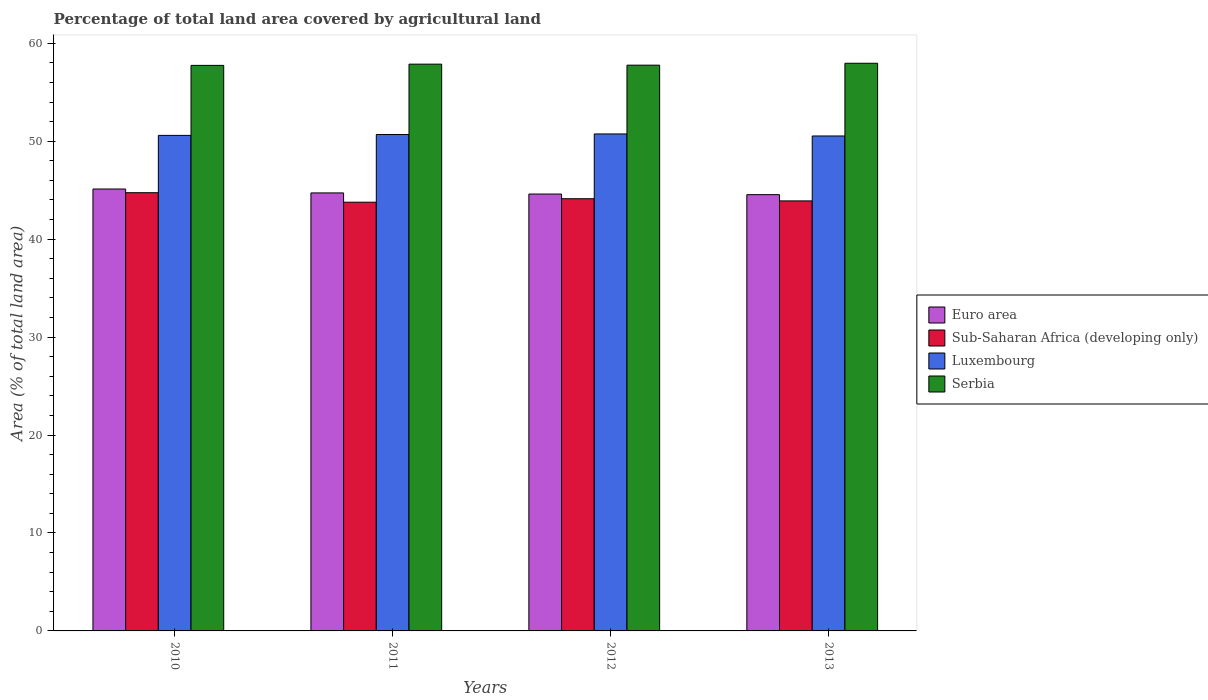Are the number of bars per tick equal to the number of legend labels?
Your answer should be compact. Yes. How many bars are there on the 2nd tick from the left?
Offer a terse response. 4. What is the label of the 4th group of bars from the left?
Keep it short and to the point. 2013. What is the percentage of agricultural land in Sub-Saharan Africa (developing only) in 2011?
Ensure brevity in your answer.  43.77. Across all years, what is the maximum percentage of agricultural land in Euro area?
Your answer should be compact. 45.12. Across all years, what is the minimum percentage of agricultural land in Serbia?
Make the answer very short. 57.74. In which year was the percentage of agricultural land in Serbia maximum?
Your answer should be very brief. 2013. In which year was the percentage of agricultural land in Serbia minimum?
Your response must be concise. 2010. What is the total percentage of agricultural land in Luxembourg in the graph?
Offer a very short reply. 202.55. What is the difference between the percentage of agricultural land in Serbia in 2010 and that in 2013?
Give a very brief answer. -0.22. What is the difference between the percentage of agricultural land in Serbia in 2011 and the percentage of agricultural land in Luxembourg in 2013?
Your answer should be very brief. 7.33. What is the average percentage of agricultural land in Serbia per year?
Your response must be concise. 57.83. In the year 2011, what is the difference between the percentage of agricultural land in Euro area and percentage of agricultural land in Sub-Saharan Africa (developing only)?
Offer a very short reply. 0.95. What is the ratio of the percentage of agricultural land in Sub-Saharan Africa (developing only) in 2011 to that in 2013?
Provide a succinct answer. 1. Is the difference between the percentage of agricultural land in Euro area in 2011 and 2013 greater than the difference between the percentage of agricultural land in Sub-Saharan Africa (developing only) in 2011 and 2013?
Ensure brevity in your answer.  Yes. What is the difference between the highest and the second highest percentage of agricultural land in Sub-Saharan Africa (developing only)?
Provide a short and direct response. 0.62. What is the difference between the highest and the lowest percentage of agricultural land in Serbia?
Keep it short and to the point. 0.22. What does the 4th bar from the left in 2012 represents?
Your response must be concise. Serbia. What does the 1st bar from the right in 2013 represents?
Ensure brevity in your answer.  Serbia. Is it the case that in every year, the sum of the percentage of agricultural land in Serbia and percentage of agricultural land in Luxembourg is greater than the percentage of agricultural land in Euro area?
Make the answer very short. Yes. How many bars are there?
Your response must be concise. 16. Are all the bars in the graph horizontal?
Ensure brevity in your answer.  No. What is the difference between two consecutive major ticks on the Y-axis?
Offer a very short reply. 10. Are the values on the major ticks of Y-axis written in scientific E-notation?
Ensure brevity in your answer.  No. Where does the legend appear in the graph?
Give a very brief answer. Center right. What is the title of the graph?
Make the answer very short. Percentage of total land area covered by agricultural land. Does "Albania" appear as one of the legend labels in the graph?
Offer a terse response. No. What is the label or title of the X-axis?
Ensure brevity in your answer.  Years. What is the label or title of the Y-axis?
Offer a very short reply. Area (% of total land area). What is the Area (% of total land area) in Euro area in 2010?
Your answer should be very brief. 45.12. What is the Area (% of total land area) of Sub-Saharan Africa (developing only) in 2010?
Offer a terse response. 44.74. What is the Area (% of total land area) in Luxembourg in 2010?
Make the answer very short. 50.59. What is the Area (% of total land area) of Serbia in 2010?
Provide a succinct answer. 57.74. What is the Area (% of total land area) in Euro area in 2011?
Offer a very short reply. 44.72. What is the Area (% of total land area) in Sub-Saharan Africa (developing only) in 2011?
Your response must be concise. 43.77. What is the Area (% of total land area) in Luxembourg in 2011?
Give a very brief answer. 50.68. What is the Area (% of total land area) of Serbia in 2011?
Your answer should be compact. 57.87. What is the Area (% of total land area) of Euro area in 2012?
Make the answer very short. 44.61. What is the Area (% of total land area) of Sub-Saharan Africa (developing only) in 2012?
Provide a short and direct response. 44.13. What is the Area (% of total land area) of Luxembourg in 2012?
Offer a very short reply. 50.74. What is the Area (% of total land area) in Serbia in 2012?
Provide a short and direct response. 57.76. What is the Area (% of total land area) in Euro area in 2013?
Provide a short and direct response. 44.54. What is the Area (% of total land area) of Sub-Saharan Africa (developing only) in 2013?
Offer a terse response. 43.9. What is the Area (% of total land area) in Luxembourg in 2013?
Your answer should be very brief. 50.53. What is the Area (% of total land area) in Serbia in 2013?
Give a very brief answer. 57.96. Across all years, what is the maximum Area (% of total land area) of Euro area?
Keep it short and to the point. 45.12. Across all years, what is the maximum Area (% of total land area) of Sub-Saharan Africa (developing only)?
Provide a short and direct response. 44.74. Across all years, what is the maximum Area (% of total land area) of Luxembourg?
Your answer should be very brief. 50.74. Across all years, what is the maximum Area (% of total land area) of Serbia?
Ensure brevity in your answer.  57.96. Across all years, what is the minimum Area (% of total land area) of Euro area?
Keep it short and to the point. 44.54. Across all years, what is the minimum Area (% of total land area) in Sub-Saharan Africa (developing only)?
Offer a very short reply. 43.77. Across all years, what is the minimum Area (% of total land area) in Luxembourg?
Offer a very short reply. 50.53. Across all years, what is the minimum Area (% of total land area) in Serbia?
Offer a very short reply. 57.74. What is the total Area (% of total land area) of Euro area in the graph?
Make the answer very short. 178.99. What is the total Area (% of total land area) in Sub-Saharan Africa (developing only) in the graph?
Your answer should be compact. 176.55. What is the total Area (% of total land area) in Luxembourg in the graph?
Provide a succinct answer. 202.55. What is the total Area (% of total land area) in Serbia in the graph?
Your answer should be very brief. 231.33. What is the difference between the Area (% of total land area) in Euro area in 2010 and that in 2011?
Ensure brevity in your answer.  0.4. What is the difference between the Area (% of total land area) of Sub-Saharan Africa (developing only) in 2010 and that in 2011?
Offer a terse response. 0.97. What is the difference between the Area (% of total land area) in Luxembourg in 2010 and that in 2011?
Give a very brief answer. -0.09. What is the difference between the Area (% of total land area) of Serbia in 2010 and that in 2011?
Your answer should be very brief. -0.13. What is the difference between the Area (% of total land area) in Euro area in 2010 and that in 2012?
Your answer should be compact. 0.51. What is the difference between the Area (% of total land area) in Sub-Saharan Africa (developing only) in 2010 and that in 2012?
Make the answer very short. 0.62. What is the difference between the Area (% of total land area) of Luxembourg in 2010 and that in 2012?
Your response must be concise. -0.15. What is the difference between the Area (% of total land area) in Serbia in 2010 and that in 2012?
Provide a succinct answer. -0.02. What is the difference between the Area (% of total land area) of Euro area in 2010 and that in 2013?
Make the answer very short. 0.58. What is the difference between the Area (% of total land area) of Sub-Saharan Africa (developing only) in 2010 and that in 2013?
Make the answer very short. 0.84. What is the difference between the Area (% of total land area) in Luxembourg in 2010 and that in 2013?
Make the answer very short. 0.06. What is the difference between the Area (% of total land area) of Serbia in 2010 and that in 2013?
Offer a very short reply. -0.22. What is the difference between the Area (% of total land area) of Euro area in 2011 and that in 2012?
Your answer should be compact. 0.11. What is the difference between the Area (% of total land area) of Sub-Saharan Africa (developing only) in 2011 and that in 2012?
Keep it short and to the point. -0.35. What is the difference between the Area (% of total land area) of Luxembourg in 2011 and that in 2012?
Your answer should be compact. -0.06. What is the difference between the Area (% of total land area) of Serbia in 2011 and that in 2012?
Offer a terse response. 0.1. What is the difference between the Area (% of total land area) of Euro area in 2011 and that in 2013?
Your response must be concise. 0.18. What is the difference between the Area (% of total land area) in Sub-Saharan Africa (developing only) in 2011 and that in 2013?
Provide a short and direct response. -0.13. What is the difference between the Area (% of total land area) of Luxembourg in 2011 and that in 2013?
Your response must be concise. 0.15. What is the difference between the Area (% of total land area) of Serbia in 2011 and that in 2013?
Your response must be concise. -0.09. What is the difference between the Area (% of total land area) of Euro area in 2012 and that in 2013?
Provide a short and direct response. 0.06. What is the difference between the Area (% of total land area) in Sub-Saharan Africa (developing only) in 2012 and that in 2013?
Provide a succinct answer. 0.22. What is the difference between the Area (% of total land area) of Luxembourg in 2012 and that in 2013?
Keep it short and to the point. 0.21. What is the difference between the Area (% of total land area) of Serbia in 2012 and that in 2013?
Your answer should be very brief. -0.19. What is the difference between the Area (% of total land area) of Euro area in 2010 and the Area (% of total land area) of Sub-Saharan Africa (developing only) in 2011?
Your answer should be very brief. 1.35. What is the difference between the Area (% of total land area) of Euro area in 2010 and the Area (% of total land area) of Luxembourg in 2011?
Keep it short and to the point. -5.56. What is the difference between the Area (% of total land area) in Euro area in 2010 and the Area (% of total land area) in Serbia in 2011?
Your response must be concise. -12.75. What is the difference between the Area (% of total land area) in Sub-Saharan Africa (developing only) in 2010 and the Area (% of total land area) in Luxembourg in 2011?
Offer a terse response. -5.94. What is the difference between the Area (% of total land area) in Sub-Saharan Africa (developing only) in 2010 and the Area (% of total land area) in Serbia in 2011?
Offer a very short reply. -13.12. What is the difference between the Area (% of total land area) of Luxembourg in 2010 and the Area (% of total land area) of Serbia in 2011?
Offer a very short reply. -7.27. What is the difference between the Area (% of total land area) in Euro area in 2010 and the Area (% of total land area) in Luxembourg in 2012?
Provide a short and direct response. -5.62. What is the difference between the Area (% of total land area) in Euro area in 2010 and the Area (% of total land area) in Serbia in 2012?
Ensure brevity in your answer.  -12.64. What is the difference between the Area (% of total land area) of Sub-Saharan Africa (developing only) in 2010 and the Area (% of total land area) of Luxembourg in 2012?
Offer a terse response. -6. What is the difference between the Area (% of total land area) in Sub-Saharan Africa (developing only) in 2010 and the Area (% of total land area) in Serbia in 2012?
Your response must be concise. -13.02. What is the difference between the Area (% of total land area) of Luxembourg in 2010 and the Area (% of total land area) of Serbia in 2012?
Your response must be concise. -7.17. What is the difference between the Area (% of total land area) of Euro area in 2010 and the Area (% of total land area) of Sub-Saharan Africa (developing only) in 2013?
Provide a succinct answer. 1.21. What is the difference between the Area (% of total land area) of Euro area in 2010 and the Area (% of total land area) of Luxembourg in 2013?
Give a very brief answer. -5.41. What is the difference between the Area (% of total land area) of Euro area in 2010 and the Area (% of total land area) of Serbia in 2013?
Offer a terse response. -12.84. What is the difference between the Area (% of total land area) in Sub-Saharan Africa (developing only) in 2010 and the Area (% of total land area) in Luxembourg in 2013?
Your answer should be very brief. -5.79. What is the difference between the Area (% of total land area) in Sub-Saharan Africa (developing only) in 2010 and the Area (% of total land area) in Serbia in 2013?
Provide a short and direct response. -13.22. What is the difference between the Area (% of total land area) of Luxembourg in 2010 and the Area (% of total land area) of Serbia in 2013?
Keep it short and to the point. -7.36. What is the difference between the Area (% of total land area) of Euro area in 2011 and the Area (% of total land area) of Sub-Saharan Africa (developing only) in 2012?
Offer a terse response. 0.59. What is the difference between the Area (% of total land area) in Euro area in 2011 and the Area (% of total land area) in Luxembourg in 2012?
Offer a terse response. -6.02. What is the difference between the Area (% of total land area) of Euro area in 2011 and the Area (% of total land area) of Serbia in 2012?
Make the answer very short. -13.04. What is the difference between the Area (% of total land area) of Sub-Saharan Africa (developing only) in 2011 and the Area (% of total land area) of Luxembourg in 2012?
Give a very brief answer. -6.97. What is the difference between the Area (% of total land area) of Sub-Saharan Africa (developing only) in 2011 and the Area (% of total land area) of Serbia in 2012?
Ensure brevity in your answer.  -13.99. What is the difference between the Area (% of total land area) of Luxembourg in 2011 and the Area (% of total land area) of Serbia in 2012?
Provide a succinct answer. -7.08. What is the difference between the Area (% of total land area) in Euro area in 2011 and the Area (% of total land area) in Sub-Saharan Africa (developing only) in 2013?
Your answer should be very brief. 0.81. What is the difference between the Area (% of total land area) in Euro area in 2011 and the Area (% of total land area) in Luxembourg in 2013?
Your response must be concise. -5.81. What is the difference between the Area (% of total land area) in Euro area in 2011 and the Area (% of total land area) in Serbia in 2013?
Ensure brevity in your answer.  -13.24. What is the difference between the Area (% of total land area) of Sub-Saharan Africa (developing only) in 2011 and the Area (% of total land area) of Luxembourg in 2013?
Keep it short and to the point. -6.76. What is the difference between the Area (% of total land area) in Sub-Saharan Africa (developing only) in 2011 and the Area (% of total land area) in Serbia in 2013?
Offer a very short reply. -14.19. What is the difference between the Area (% of total land area) of Luxembourg in 2011 and the Area (% of total land area) of Serbia in 2013?
Ensure brevity in your answer.  -7.27. What is the difference between the Area (% of total land area) in Euro area in 2012 and the Area (% of total land area) in Sub-Saharan Africa (developing only) in 2013?
Provide a short and direct response. 0.7. What is the difference between the Area (% of total land area) in Euro area in 2012 and the Area (% of total land area) in Luxembourg in 2013?
Offer a very short reply. -5.93. What is the difference between the Area (% of total land area) in Euro area in 2012 and the Area (% of total land area) in Serbia in 2013?
Offer a terse response. -13.35. What is the difference between the Area (% of total land area) of Sub-Saharan Africa (developing only) in 2012 and the Area (% of total land area) of Luxembourg in 2013?
Your response must be concise. -6.41. What is the difference between the Area (% of total land area) of Sub-Saharan Africa (developing only) in 2012 and the Area (% of total land area) of Serbia in 2013?
Your answer should be compact. -13.83. What is the difference between the Area (% of total land area) of Luxembourg in 2012 and the Area (% of total land area) of Serbia in 2013?
Your answer should be very brief. -7.22. What is the average Area (% of total land area) of Euro area per year?
Your response must be concise. 44.75. What is the average Area (% of total land area) of Sub-Saharan Africa (developing only) per year?
Ensure brevity in your answer.  44.14. What is the average Area (% of total land area) of Luxembourg per year?
Give a very brief answer. 50.64. What is the average Area (% of total land area) in Serbia per year?
Ensure brevity in your answer.  57.83. In the year 2010, what is the difference between the Area (% of total land area) in Euro area and Area (% of total land area) in Sub-Saharan Africa (developing only)?
Your answer should be very brief. 0.38. In the year 2010, what is the difference between the Area (% of total land area) of Euro area and Area (% of total land area) of Luxembourg?
Your answer should be compact. -5.48. In the year 2010, what is the difference between the Area (% of total land area) in Euro area and Area (% of total land area) in Serbia?
Provide a succinct answer. -12.62. In the year 2010, what is the difference between the Area (% of total land area) of Sub-Saharan Africa (developing only) and Area (% of total land area) of Luxembourg?
Your answer should be very brief. -5.85. In the year 2010, what is the difference between the Area (% of total land area) in Sub-Saharan Africa (developing only) and Area (% of total land area) in Serbia?
Make the answer very short. -13. In the year 2010, what is the difference between the Area (% of total land area) in Luxembourg and Area (% of total land area) in Serbia?
Your response must be concise. -7.15. In the year 2011, what is the difference between the Area (% of total land area) in Euro area and Area (% of total land area) in Sub-Saharan Africa (developing only)?
Give a very brief answer. 0.95. In the year 2011, what is the difference between the Area (% of total land area) of Euro area and Area (% of total land area) of Luxembourg?
Give a very brief answer. -5.96. In the year 2011, what is the difference between the Area (% of total land area) of Euro area and Area (% of total land area) of Serbia?
Give a very brief answer. -13.15. In the year 2011, what is the difference between the Area (% of total land area) of Sub-Saharan Africa (developing only) and Area (% of total land area) of Luxembourg?
Ensure brevity in your answer.  -6.91. In the year 2011, what is the difference between the Area (% of total land area) of Sub-Saharan Africa (developing only) and Area (% of total land area) of Serbia?
Your answer should be compact. -14.09. In the year 2011, what is the difference between the Area (% of total land area) of Luxembourg and Area (% of total land area) of Serbia?
Give a very brief answer. -7.18. In the year 2012, what is the difference between the Area (% of total land area) in Euro area and Area (% of total land area) in Sub-Saharan Africa (developing only)?
Offer a terse response. 0.48. In the year 2012, what is the difference between the Area (% of total land area) of Euro area and Area (% of total land area) of Luxembourg?
Your answer should be compact. -6.14. In the year 2012, what is the difference between the Area (% of total land area) in Euro area and Area (% of total land area) in Serbia?
Your answer should be compact. -13.16. In the year 2012, what is the difference between the Area (% of total land area) of Sub-Saharan Africa (developing only) and Area (% of total land area) of Luxembourg?
Offer a terse response. -6.61. In the year 2012, what is the difference between the Area (% of total land area) of Sub-Saharan Africa (developing only) and Area (% of total land area) of Serbia?
Provide a short and direct response. -13.64. In the year 2012, what is the difference between the Area (% of total land area) in Luxembourg and Area (% of total land area) in Serbia?
Give a very brief answer. -7.02. In the year 2013, what is the difference between the Area (% of total land area) of Euro area and Area (% of total land area) of Sub-Saharan Africa (developing only)?
Offer a terse response. 0.64. In the year 2013, what is the difference between the Area (% of total land area) of Euro area and Area (% of total land area) of Luxembourg?
Your answer should be very brief. -5.99. In the year 2013, what is the difference between the Area (% of total land area) of Euro area and Area (% of total land area) of Serbia?
Provide a short and direct response. -13.42. In the year 2013, what is the difference between the Area (% of total land area) of Sub-Saharan Africa (developing only) and Area (% of total land area) of Luxembourg?
Provide a succinct answer. -6.63. In the year 2013, what is the difference between the Area (% of total land area) in Sub-Saharan Africa (developing only) and Area (% of total land area) in Serbia?
Offer a very short reply. -14.05. In the year 2013, what is the difference between the Area (% of total land area) of Luxembourg and Area (% of total land area) of Serbia?
Make the answer very short. -7.43. What is the ratio of the Area (% of total land area) in Euro area in 2010 to that in 2011?
Provide a short and direct response. 1.01. What is the ratio of the Area (% of total land area) in Sub-Saharan Africa (developing only) in 2010 to that in 2011?
Keep it short and to the point. 1.02. What is the ratio of the Area (% of total land area) of Luxembourg in 2010 to that in 2011?
Ensure brevity in your answer.  1. What is the ratio of the Area (% of total land area) in Serbia in 2010 to that in 2011?
Make the answer very short. 1. What is the ratio of the Area (% of total land area) in Euro area in 2010 to that in 2012?
Your answer should be very brief. 1.01. What is the ratio of the Area (% of total land area) in Sub-Saharan Africa (developing only) in 2010 to that in 2012?
Your answer should be very brief. 1.01. What is the ratio of the Area (% of total land area) in Luxembourg in 2010 to that in 2012?
Your answer should be very brief. 1. What is the ratio of the Area (% of total land area) of Euro area in 2010 to that in 2013?
Provide a succinct answer. 1.01. What is the ratio of the Area (% of total land area) of Sub-Saharan Africa (developing only) in 2010 to that in 2013?
Your answer should be compact. 1.02. What is the ratio of the Area (% of total land area) in Luxembourg in 2010 to that in 2013?
Your response must be concise. 1. What is the ratio of the Area (% of total land area) of Euro area in 2011 to that in 2012?
Ensure brevity in your answer.  1. What is the ratio of the Area (% of total land area) in Serbia in 2011 to that in 2012?
Your response must be concise. 1. What is the ratio of the Area (% of total land area) of Euro area in 2011 to that in 2013?
Your answer should be compact. 1. What is the ratio of the Area (% of total land area) in Sub-Saharan Africa (developing only) in 2012 to that in 2013?
Your answer should be compact. 1.01. What is the ratio of the Area (% of total land area) in Luxembourg in 2012 to that in 2013?
Give a very brief answer. 1. What is the ratio of the Area (% of total land area) of Serbia in 2012 to that in 2013?
Provide a short and direct response. 1. What is the difference between the highest and the second highest Area (% of total land area) of Euro area?
Your answer should be very brief. 0.4. What is the difference between the highest and the second highest Area (% of total land area) of Sub-Saharan Africa (developing only)?
Your answer should be very brief. 0.62. What is the difference between the highest and the second highest Area (% of total land area) in Luxembourg?
Provide a succinct answer. 0.06. What is the difference between the highest and the second highest Area (% of total land area) of Serbia?
Offer a terse response. 0.09. What is the difference between the highest and the lowest Area (% of total land area) of Euro area?
Give a very brief answer. 0.58. What is the difference between the highest and the lowest Area (% of total land area) of Sub-Saharan Africa (developing only)?
Provide a succinct answer. 0.97. What is the difference between the highest and the lowest Area (% of total land area) of Luxembourg?
Give a very brief answer. 0.21. What is the difference between the highest and the lowest Area (% of total land area) in Serbia?
Your answer should be compact. 0.22. 